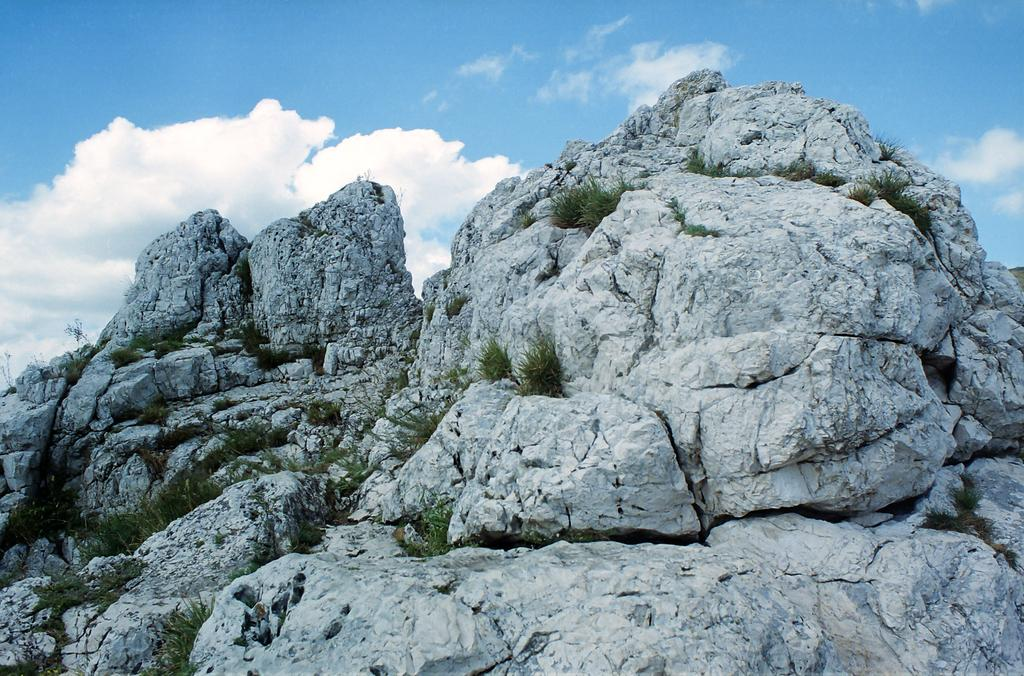What is the main feature in the picture? There is a mountain in the picture. What type of vegetation can be seen on the mountain? There is grass on the mountain. What is the condition of the sky in the picture? The sky is clear in the picture. What type of music is being played by the father in the picture? There is no father or music present in the picture; it features a mountain with grass and a clear sky. 